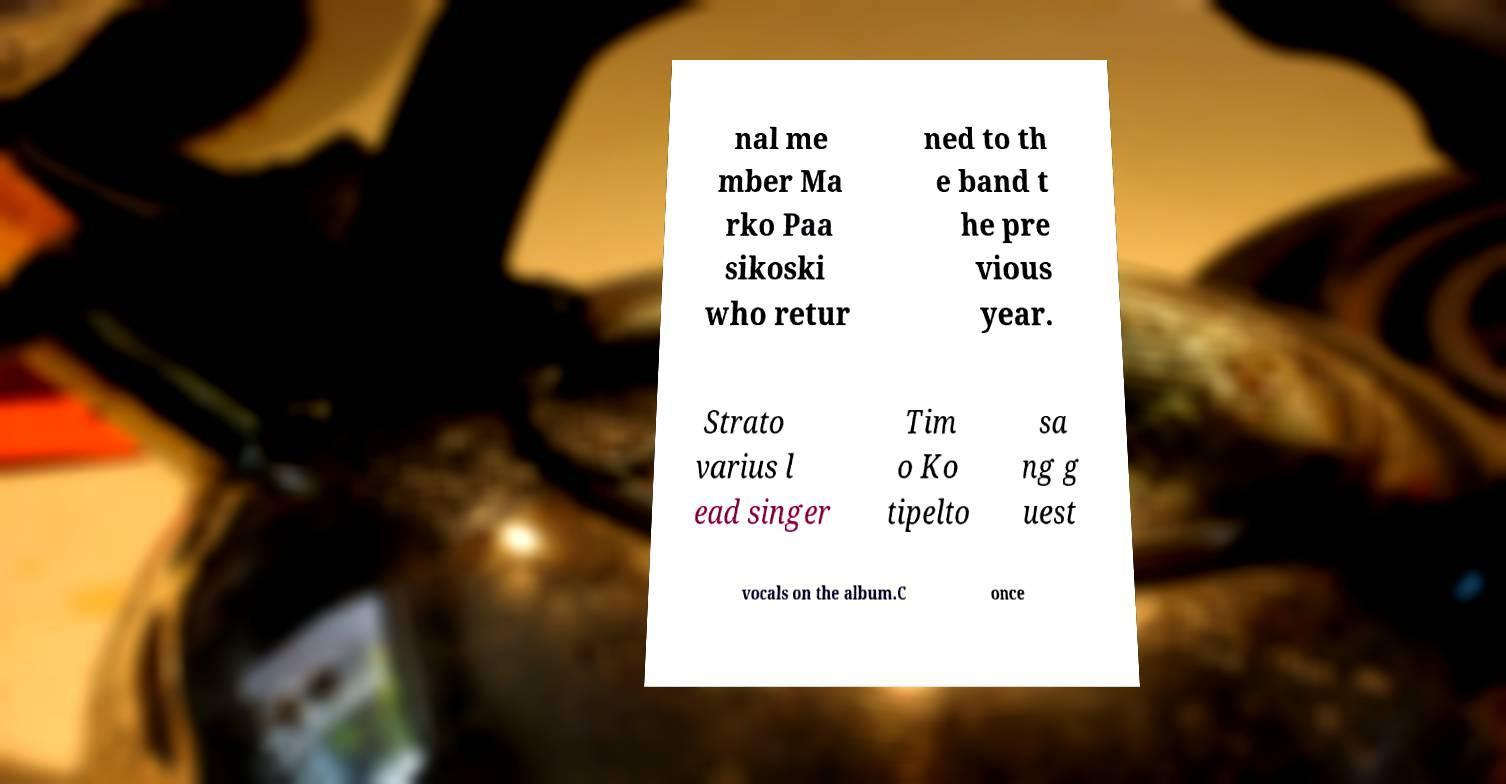Can you accurately transcribe the text from the provided image for me? nal me mber Ma rko Paa sikoski who retur ned to th e band t he pre vious year. Strato varius l ead singer Tim o Ko tipelto sa ng g uest vocals on the album.C once 